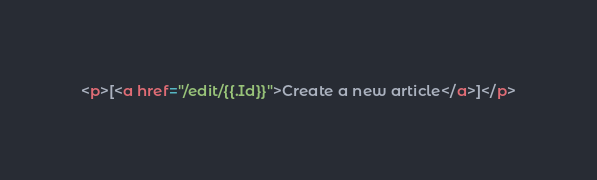<code> <loc_0><loc_0><loc_500><loc_500><_HTML_><p>[<a href="/edit/{{.Id}}">Create a new article</a>]</p></code> 